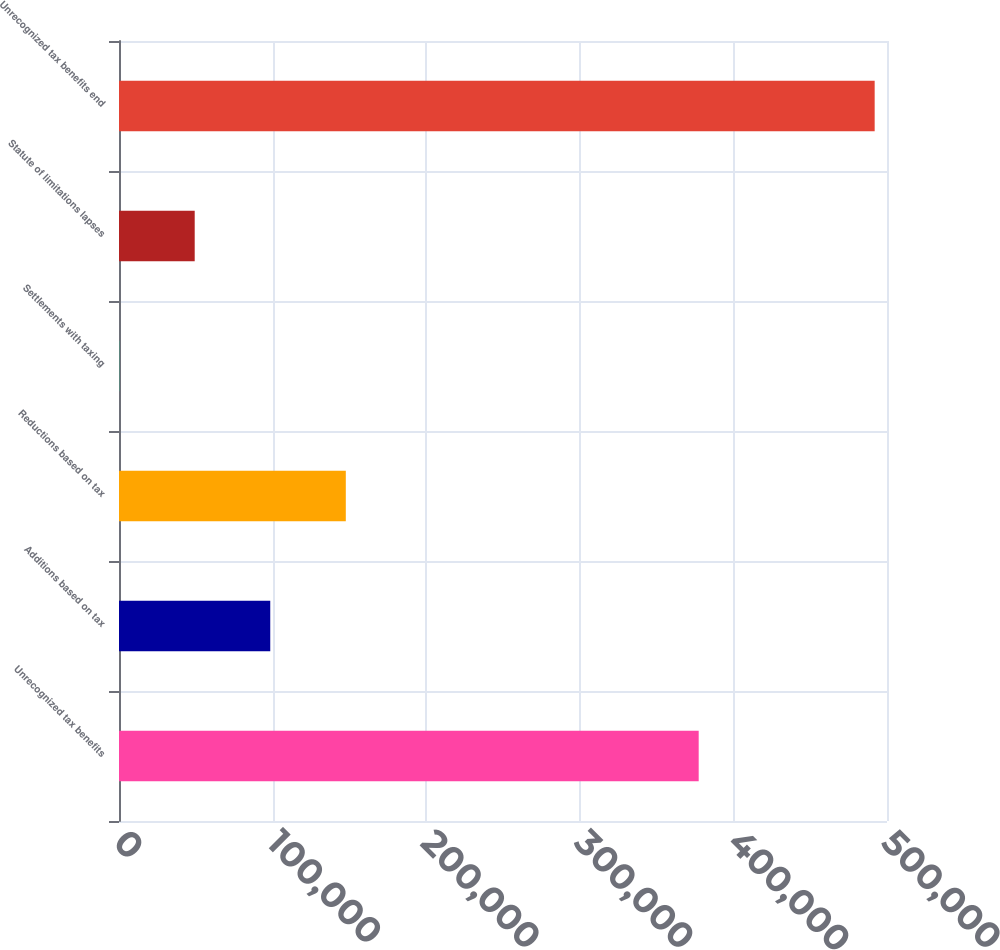<chart> <loc_0><loc_0><loc_500><loc_500><bar_chart><fcel>Unrecognized tax benefits<fcel>Additions based on tax<fcel>Reductions based on tax<fcel>Settlements with taxing<fcel>Statute of limitations lapses<fcel>Unrecognized tax benefits end<nl><fcel>377405<fcel>98473.8<fcel>147661<fcel>99<fcel>49286.4<fcel>491973<nl></chart> 